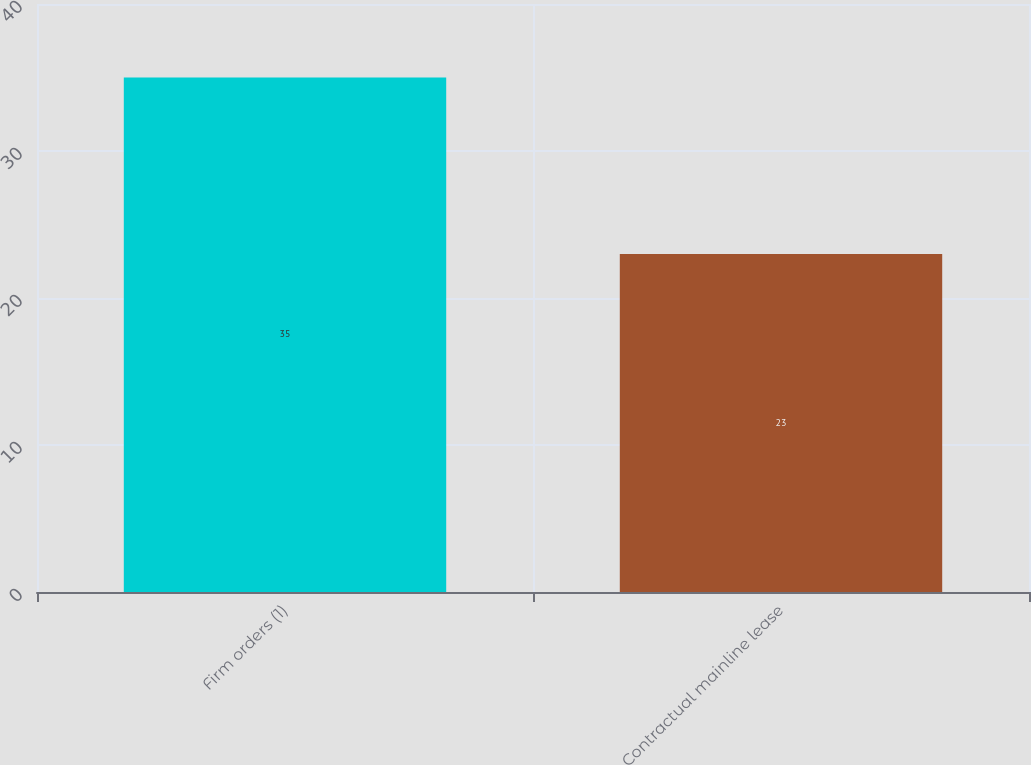Convert chart to OTSL. <chart><loc_0><loc_0><loc_500><loc_500><bar_chart><fcel>Firm orders (1)<fcel>Contractual mainline lease<nl><fcel>35<fcel>23<nl></chart> 